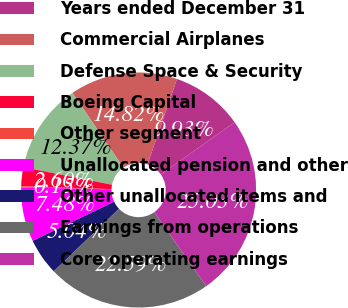Convert chart. <chart><loc_0><loc_0><loc_500><loc_500><pie_chart><fcel>Years ended December 31<fcel>Commercial Airplanes<fcel>Defense Space & Security<fcel>Boeing Capital<fcel>Other segment<fcel>Unallocated pension and other<fcel>Other unallocated items and<fcel>Earnings from operations<fcel>Core operating earnings<nl><fcel>9.93%<fcel>14.82%<fcel>12.37%<fcel>2.6%<fcel>0.15%<fcel>7.48%<fcel>5.04%<fcel>22.59%<fcel>25.03%<nl></chart> 